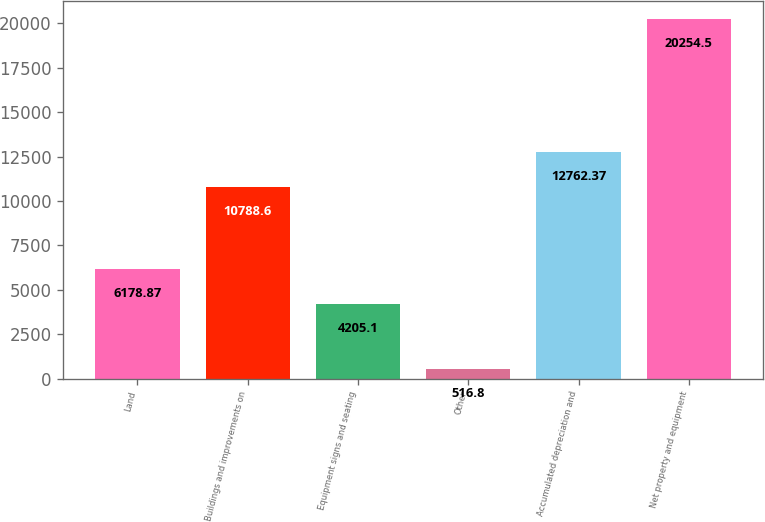<chart> <loc_0><loc_0><loc_500><loc_500><bar_chart><fcel>Land<fcel>Buildings and improvements on<fcel>Equipment signs and seating<fcel>Other<fcel>Accumulated depreciation and<fcel>Net property and equipment<nl><fcel>6178.87<fcel>10788.6<fcel>4205.1<fcel>516.8<fcel>12762.4<fcel>20254.5<nl></chart> 